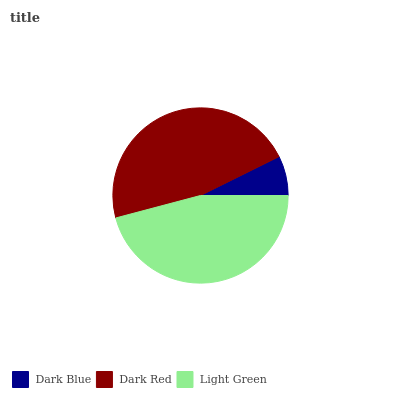Is Dark Blue the minimum?
Answer yes or no. Yes. Is Dark Red the maximum?
Answer yes or no. Yes. Is Light Green the minimum?
Answer yes or no. No. Is Light Green the maximum?
Answer yes or no. No. Is Dark Red greater than Light Green?
Answer yes or no. Yes. Is Light Green less than Dark Red?
Answer yes or no. Yes. Is Light Green greater than Dark Red?
Answer yes or no. No. Is Dark Red less than Light Green?
Answer yes or no. No. Is Light Green the high median?
Answer yes or no. Yes. Is Light Green the low median?
Answer yes or no. Yes. Is Dark Blue the high median?
Answer yes or no. No. Is Dark Red the low median?
Answer yes or no. No. 